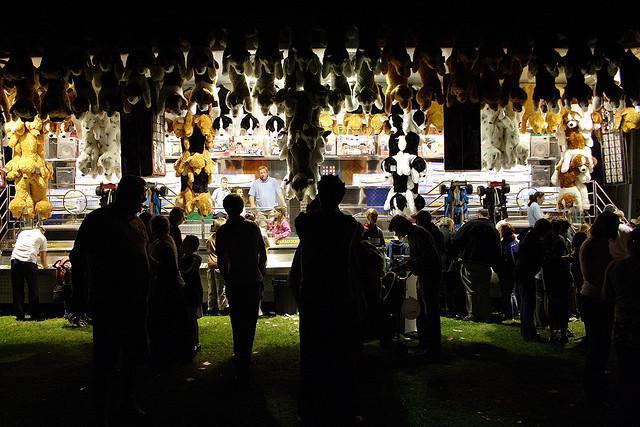How many people are in the picture?
Give a very brief answer. 8. How many donuts have chocolate frosting?
Give a very brief answer. 0. 